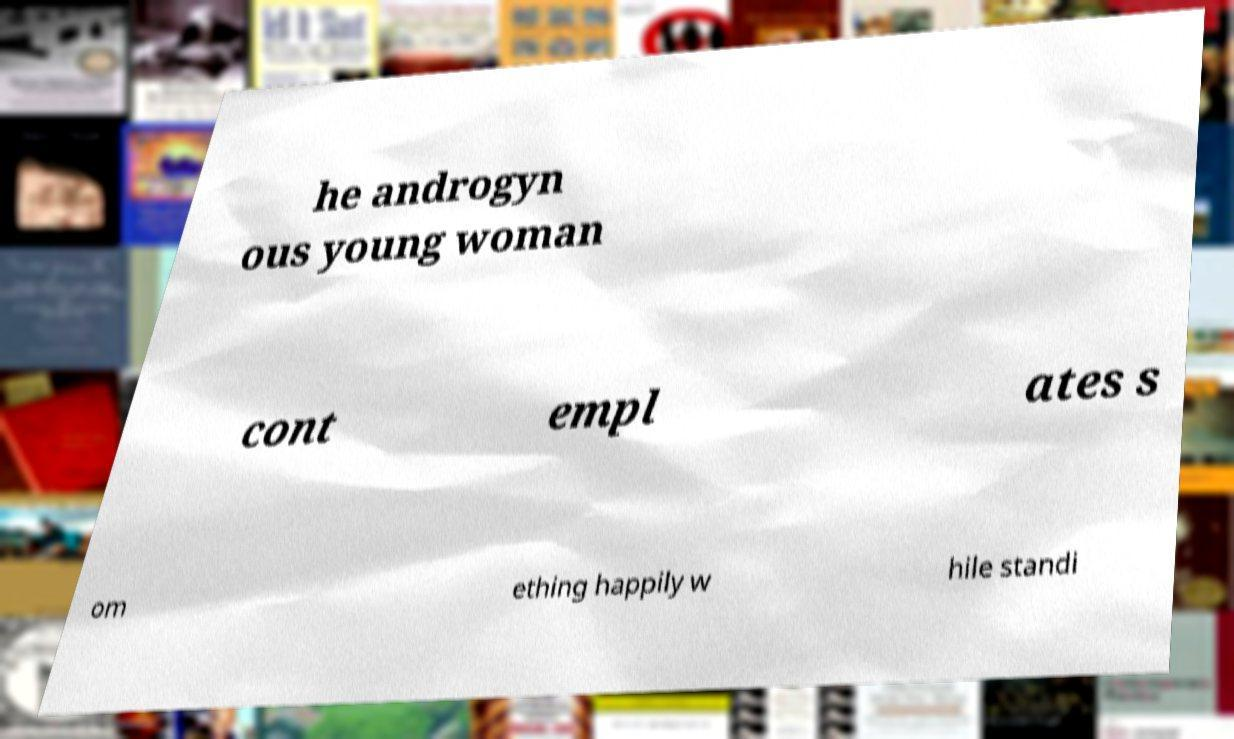Could you extract and type out the text from this image? he androgyn ous young woman cont empl ates s om ething happily w hile standi 